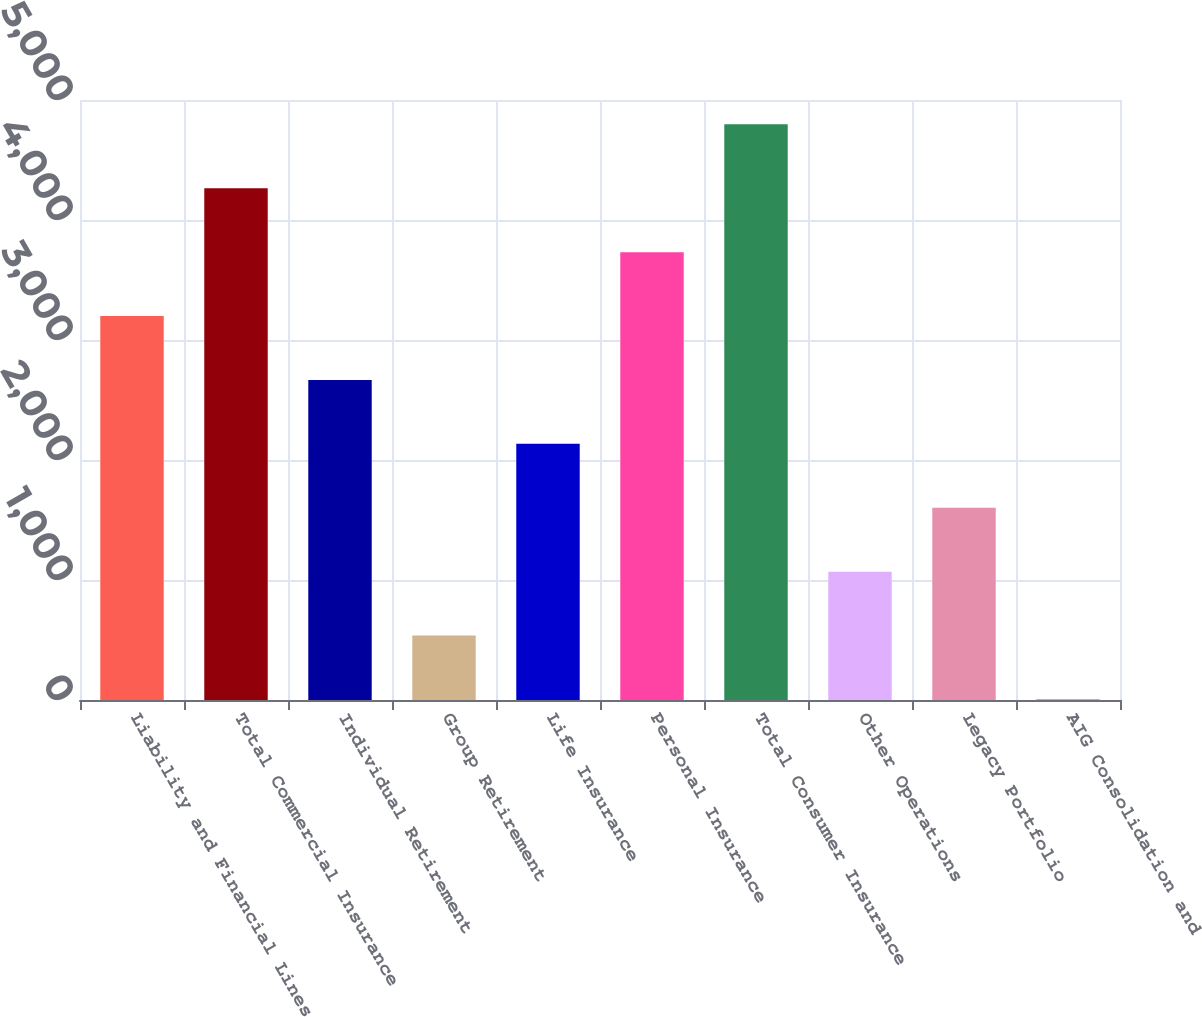<chart> <loc_0><loc_0><loc_500><loc_500><bar_chart><fcel>Liability and Financial Lines<fcel>Total Commercial Insurance<fcel>Individual Retirement<fcel>Group Retirement<fcel>Life Insurance<fcel>Personal Insurance<fcel>Total Consumer Insurance<fcel>Other Operations<fcel>Legacy Portfolio<fcel>AIG Consolidation and<nl><fcel>3199.6<fcel>4264.8<fcel>2667<fcel>536.6<fcel>2134.4<fcel>3732.2<fcel>4797.4<fcel>1069.2<fcel>1601.8<fcel>4<nl></chart> 